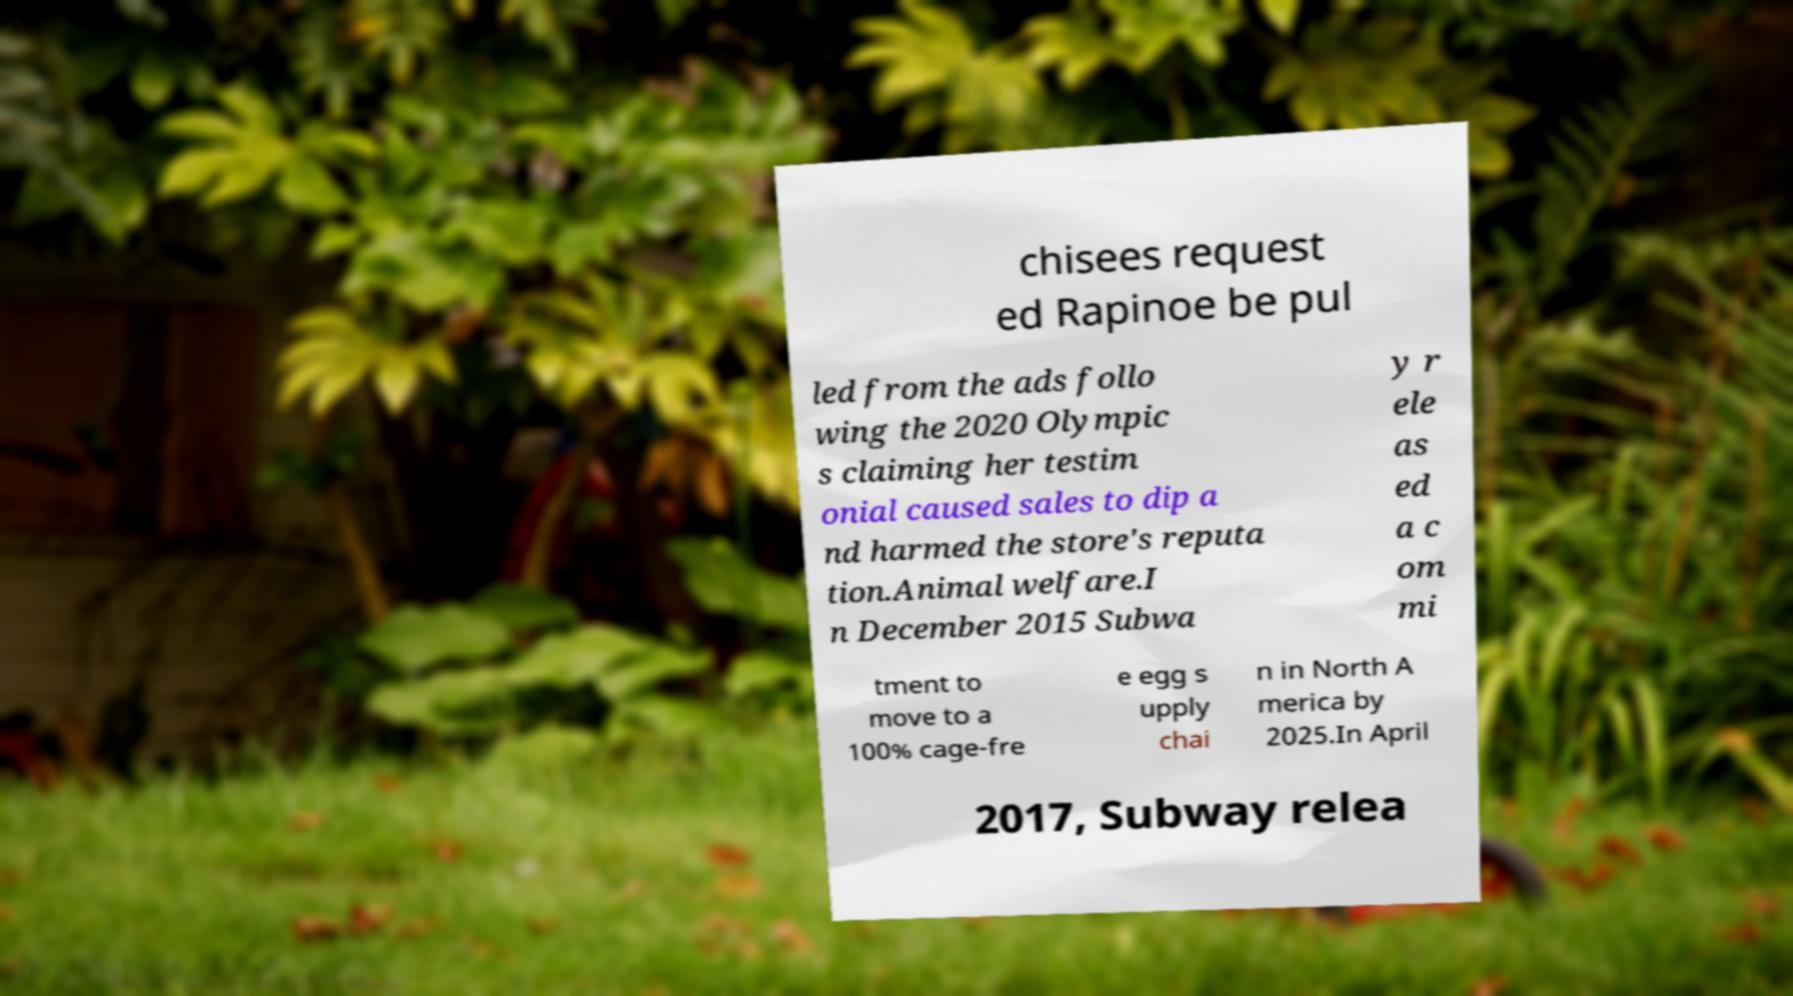Please identify and transcribe the text found in this image. chisees request ed Rapinoe be pul led from the ads follo wing the 2020 Olympic s claiming her testim onial caused sales to dip a nd harmed the store's reputa tion.Animal welfare.I n December 2015 Subwa y r ele as ed a c om mi tment to move to a 100% cage-fre e egg s upply chai n in North A merica by 2025.In April 2017, Subway relea 